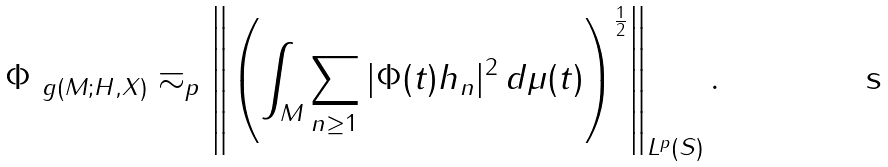<formula> <loc_0><loc_0><loc_500><loc_500>\| \Phi \| _ { \ g ( M ; H , X ) } \eqsim _ { p } \left \| \left ( \int _ { M } \sum _ { n \geq 1 } | \Phi ( t ) h _ { n } | ^ { 2 } \, d \mu ( t ) \right ) ^ { \frac { 1 } { 2 } } \right \| _ { L ^ { p } ( S ) } .</formula> 